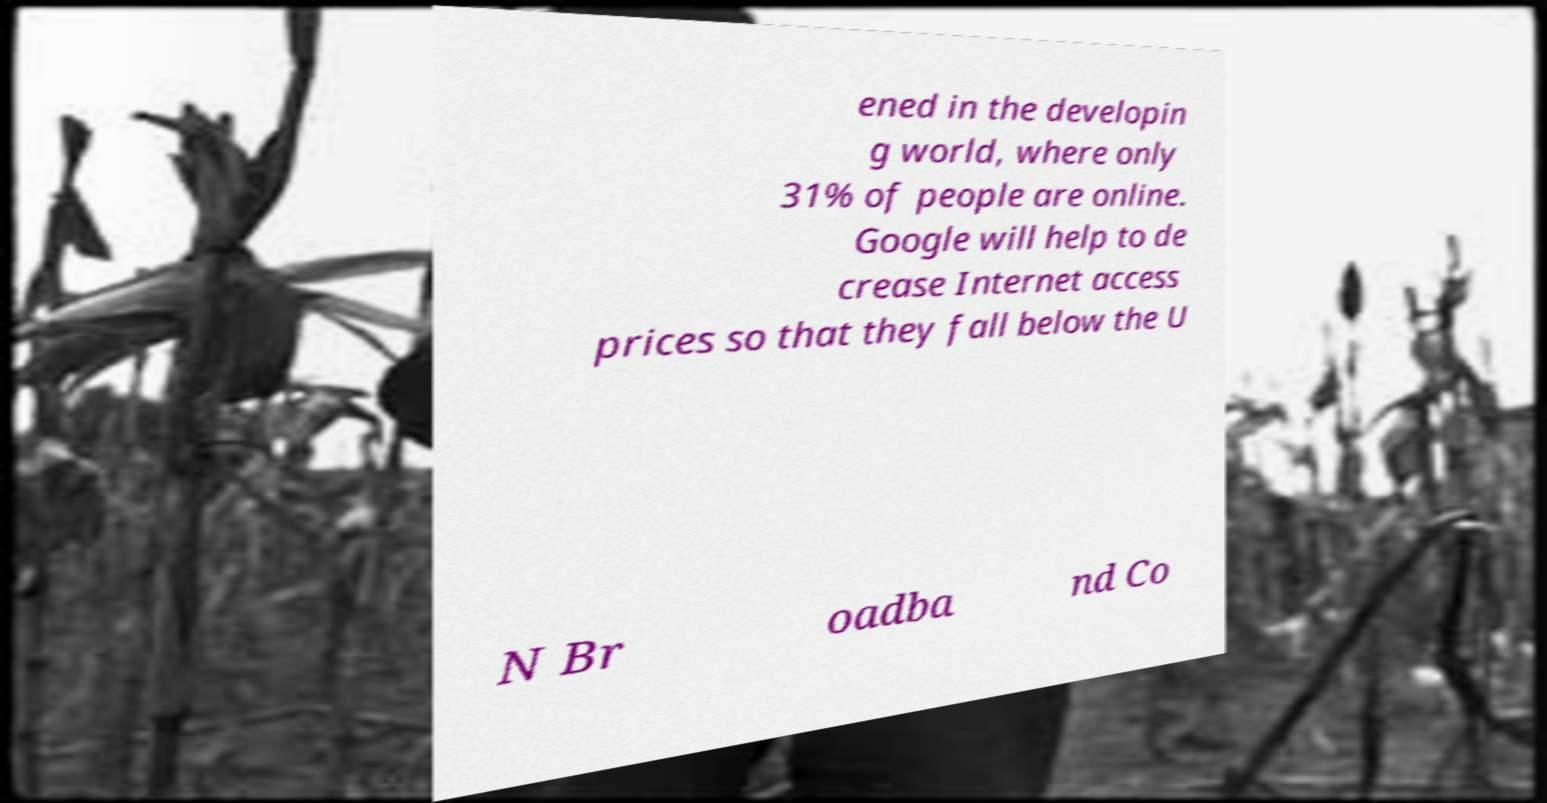Please identify and transcribe the text found in this image. ened in the developin g world, where only 31% of people are online. Google will help to de crease Internet access prices so that they fall below the U N Br oadba nd Co 